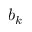Convert formula to latex. <formula><loc_0><loc_0><loc_500><loc_500>b _ { k }</formula> 